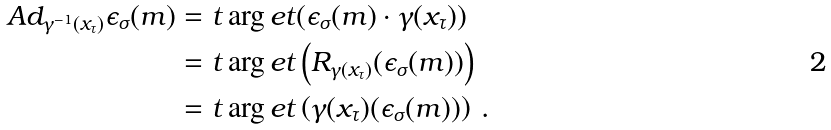Convert formula to latex. <formula><loc_0><loc_0><loc_500><loc_500>\ A d _ { \gamma ^ { - 1 } ( x _ { \tau } ) } \epsilon _ { \sigma } ( m ) = & \ t \arg e t ( \epsilon _ { \sigma } ( m ) \cdot \gamma ( x _ { \tau } ) ) \\ = & \ t \arg e t \left ( R _ { \gamma ( x _ { \tau } ) } ( \epsilon _ { \sigma } ( m ) ) \right ) \\ = & \ t \arg e t \left ( \gamma ( x _ { \tau } ) ( \epsilon _ { \sigma } ( m ) ) \right ) \, .</formula> 